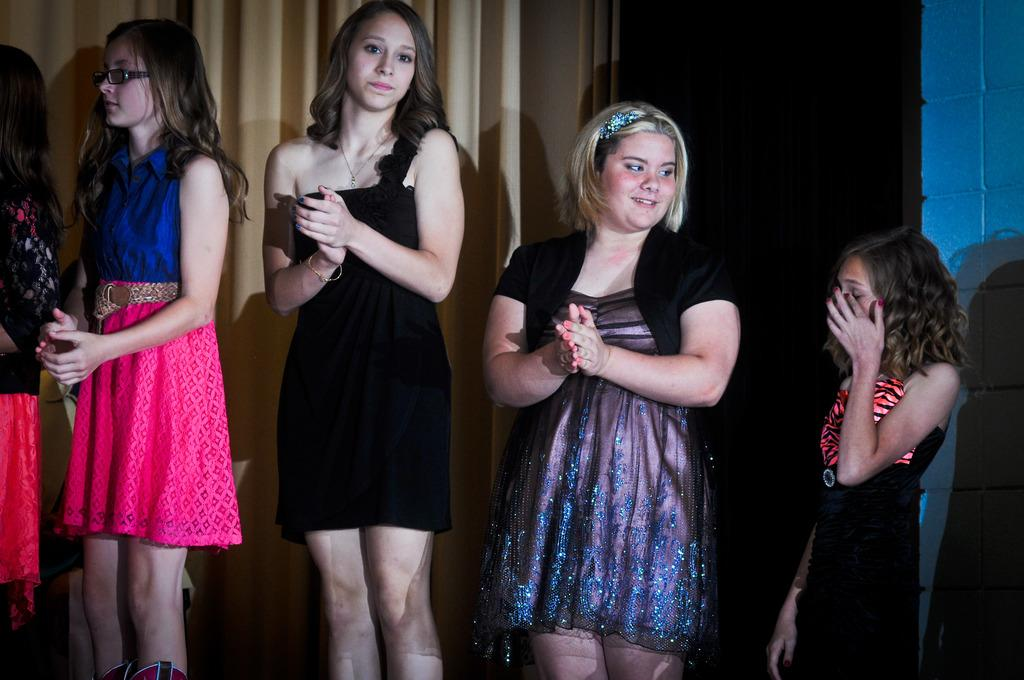What is the main subject in the foreground of the image? There is a group of girls in the foreground of the image. What are the girls doing in the image? The girls are standing and clapping. What can be seen in the background of the image? There is a curtain, a wall, and a door in the background of the image. Can you see the girls' legs touching the stream in the image? There is no stream present in the image, and the girls' legs are not touching any water. 